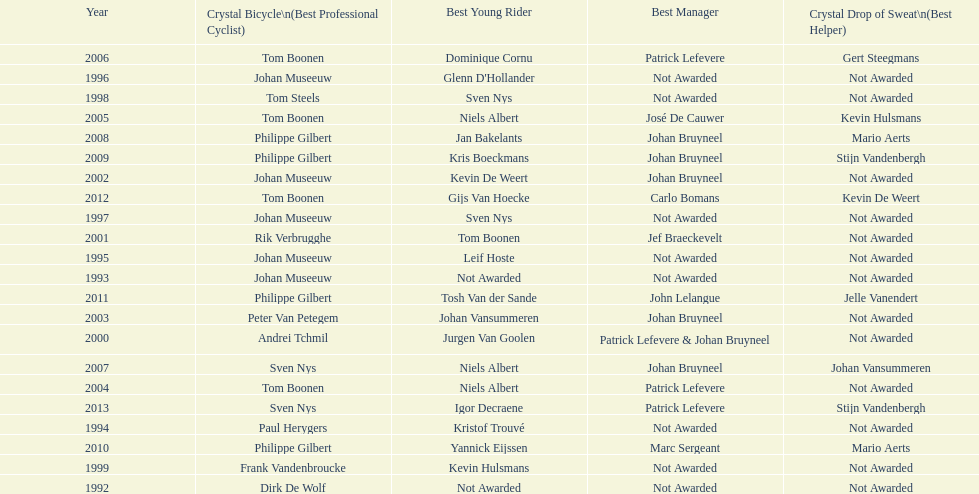Who won the most consecutive crystal bicycles? Philippe Gilbert. Can you parse all the data within this table? {'header': ['Year', 'Crystal Bicycle\\n(Best Professional Cyclist)', 'Best Young Rider', 'Best Manager', 'Crystal Drop of Sweat\\n(Best Helper)'], 'rows': [['2006', 'Tom Boonen', 'Dominique Cornu', 'Patrick Lefevere', 'Gert Steegmans'], ['1996', 'Johan Museeuw', "Glenn D'Hollander", 'Not Awarded', 'Not Awarded'], ['1998', 'Tom Steels', 'Sven Nys', 'Not Awarded', 'Not Awarded'], ['2005', 'Tom Boonen', 'Niels Albert', 'José De Cauwer', 'Kevin Hulsmans'], ['2008', 'Philippe Gilbert', 'Jan Bakelants', 'Johan Bruyneel', 'Mario Aerts'], ['2009', 'Philippe Gilbert', 'Kris Boeckmans', 'Johan Bruyneel', 'Stijn Vandenbergh'], ['2002', 'Johan Museeuw', 'Kevin De Weert', 'Johan Bruyneel', 'Not Awarded'], ['2012', 'Tom Boonen', 'Gijs Van Hoecke', 'Carlo Bomans', 'Kevin De Weert'], ['1997', 'Johan Museeuw', 'Sven Nys', 'Not Awarded', 'Not Awarded'], ['2001', 'Rik Verbrugghe', 'Tom Boonen', 'Jef Braeckevelt', 'Not Awarded'], ['1995', 'Johan Museeuw', 'Leif Hoste', 'Not Awarded', 'Not Awarded'], ['1993', 'Johan Museeuw', 'Not Awarded', 'Not Awarded', 'Not Awarded'], ['2011', 'Philippe Gilbert', 'Tosh Van der Sande', 'John Lelangue', 'Jelle Vanendert'], ['2003', 'Peter Van Petegem', 'Johan Vansummeren', 'Johan Bruyneel', 'Not Awarded'], ['2000', 'Andrei Tchmil', 'Jurgen Van Goolen', 'Patrick Lefevere & Johan Bruyneel', 'Not Awarded'], ['2007', 'Sven Nys', 'Niels Albert', 'Johan Bruyneel', 'Johan Vansummeren'], ['2004', 'Tom Boonen', 'Niels Albert', 'Patrick Lefevere', 'Not Awarded'], ['2013', 'Sven Nys', 'Igor Decraene', 'Patrick Lefevere', 'Stijn Vandenbergh'], ['1994', 'Paul Herygers', 'Kristof Trouvé', 'Not Awarded', 'Not Awarded'], ['2010', 'Philippe Gilbert', 'Yannick Eijssen', 'Marc Sergeant', 'Mario Aerts'], ['1999', 'Frank Vandenbroucke', 'Kevin Hulsmans', 'Not Awarded', 'Not Awarded'], ['1992', 'Dirk De Wolf', 'Not Awarded', 'Not Awarded', 'Not Awarded']]} 